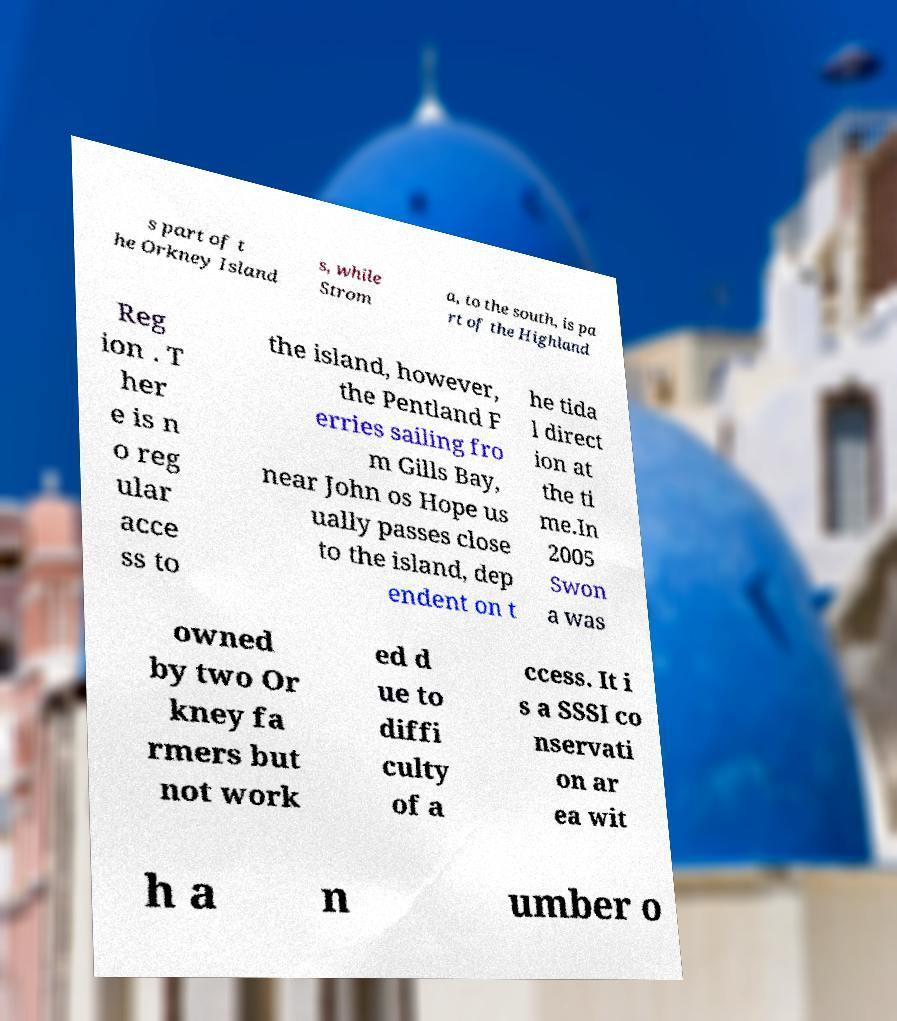Can you accurately transcribe the text from the provided image for me? s part of t he Orkney Island s, while Strom a, to the south, is pa rt of the Highland Reg ion . T her e is n o reg ular acce ss to the island, however, the Pentland F erries sailing fro m Gills Bay, near John os Hope us ually passes close to the island, dep endent on t he tida l direct ion at the ti me.In 2005 Swon a was owned by two Or kney fa rmers but not work ed d ue to diffi culty of a ccess. It i s a SSSI co nservati on ar ea wit h a n umber o 